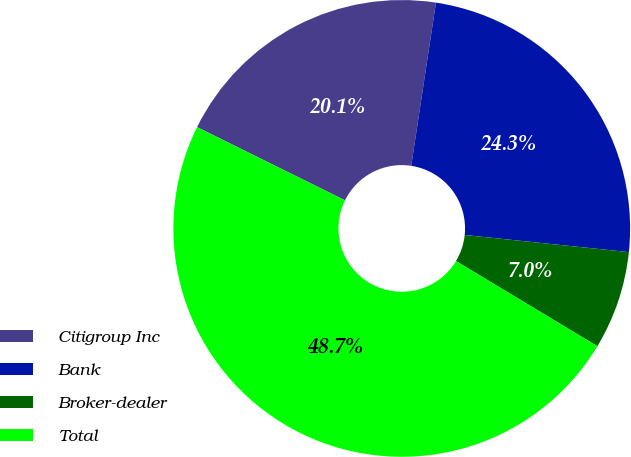Convert chart to OTSL. <chart><loc_0><loc_0><loc_500><loc_500><pie_chart><fcel>Citigroup Inc<fcel>Bank<fcel>Broker-dealer<fcel>Total<nl><fcel>20.08%<fcel>24.26%<fcel>6.97%<fcel>48.69%<nl></chart> 